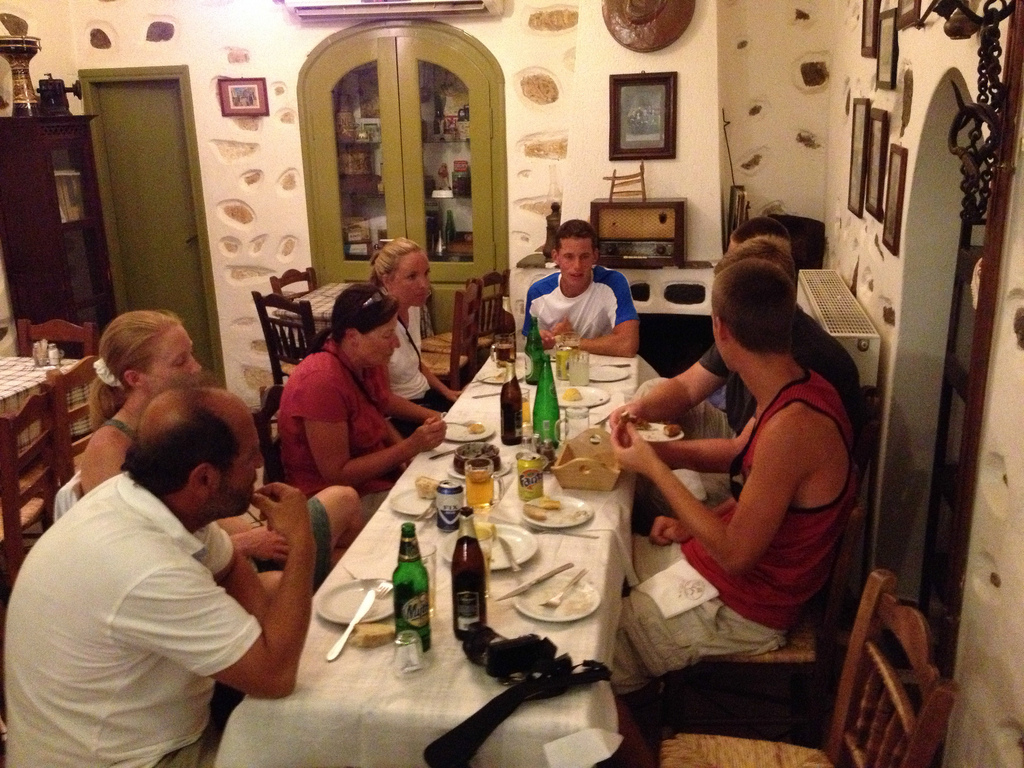What can we infer about the setting from the decor and atmosphere? The decor features rustic elements like antique wall items and traditional furniture, suggesting the setting is a quaint restaurant that offers a cozy and inviting ambiance for its guests. 